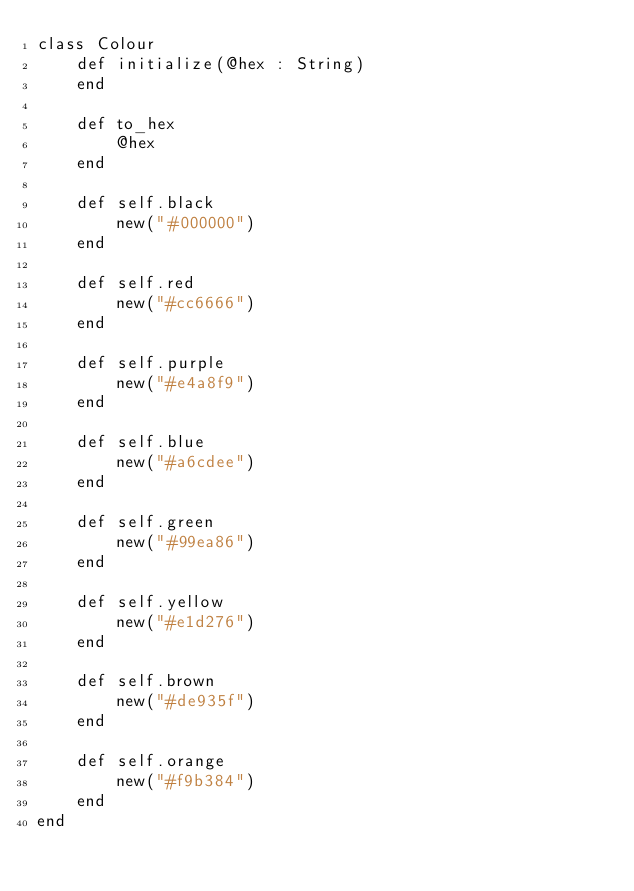<code> <loc_0><loc_0><loc_500><loc_500><_Crystal_>class Colour
    def initialize(@hex : String)
    end

    def to_hex
        @hex
    end

    def self.black
        new("#000000")
    end

    def self.red
        new("#cc6666")
    end

    def self.purple
        new("#e4a8f9")
    end

    def self.blue
        new("#a6cdee")
    end

    def self.green
        new("#99ea86")
    end

    def self.yellow
        new("#e1d276")
    end

    def self.brown
        new("#de935f")
    end

    def self.orange
        new("#f9b384")
    end
end
</code> 